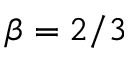Convert formula to latex. <formula><loc_0><loc_0><loc_500><loc_500>\beta = 2 / 3</formula> 